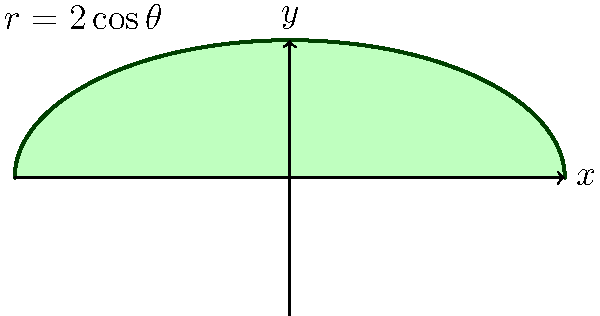Consider a lotus petal modeled by the polar equation $r=2\cos\theta$ for $0 \leq \theta \leq \pi$. Calculate the area of this petal using curve integration, reflecting on how this mathematical approach aligns with the Buddhist concept of interconnectedness in nature. To calculate the area of the lotus petal, we will use the formula for area in polar coordinates and apply the principles of curve integration. This process reflects the interconnectedness of mathematical concepts, much like the Buddhist view of interconnectedness in nature.

Step 1: Recall the formula for area in polar coordinates:
$$A = \frac{1}{2} \int_{0}^{\pi} r^2 d\theta$$

Step 2: Substitute the given equation $r = 2\cos\theta$ into the formula:
$$A = \frac{1}{2} \int_{0}^{\pi} (2\cos\theta)^2 d\theta$$

Step 3: Simplify the integrand:
$$A = \frac{1}{2} \int_{0}^{\pi} 4\cos^2\theta d\theta$$
$$A = 2 \int_{0}^{\pi} \cos^2\theta d\theta$$

Step 4: Use the trigonometric identity $\cos^2\theta = \frac{1+\cos(2\theta)}{2}$:
$$A = 2 \int_{0}^{\pi} \frac{1+\cos(2\theta)}{2} d\theta$$
$$A = \int_{0}^{\pi} (1+\cos(2\theta)) d\theta$$

Step 5: Integrate:
$$A = \left[\theta + \frac{1}{2}\sin(2\theta)\right]_{0}^{\pi}$$

Step 6: Evaluate the integral:
$$A = \left(\pi + 0\right) - \left(0 + 0\right) = \pi$$

Thus, the area of the lotus petal is $\pi$ square units. This result demonstrates how mathematical precision can reveal the elegant simplicity in natural forms, aligning with Buddhist principles of harmony and balance in the universe.
Answer: $\pi$ square units 